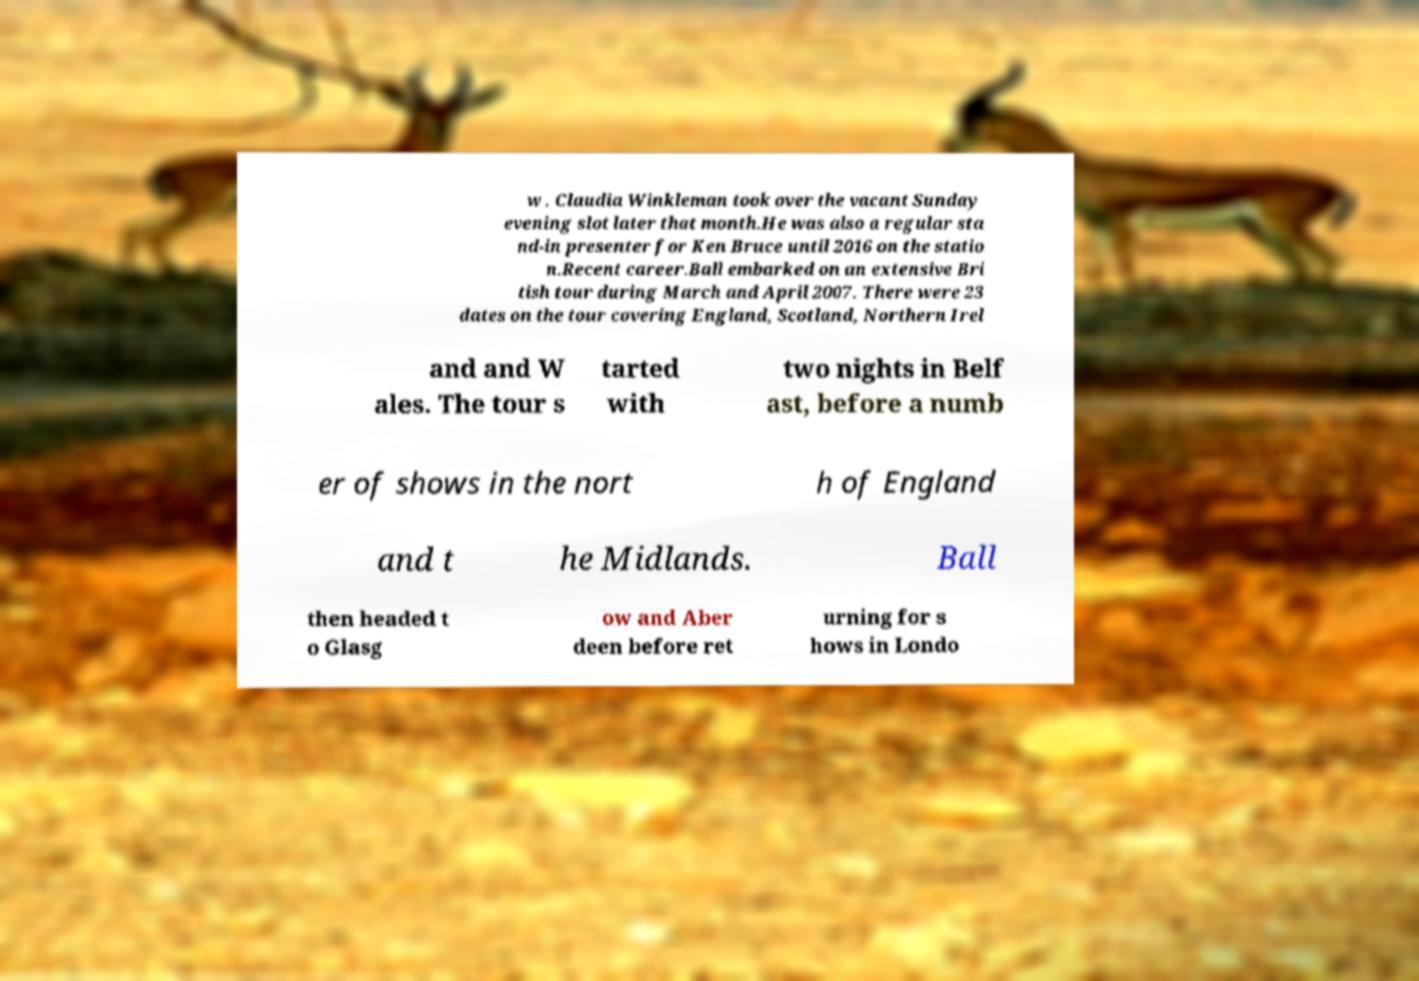Please identify and transcribe the text found in this image. w . Claudia Winkleman took over the vacant Sunday evening slot later that month.He was also a regular sta nd-in presenter for Ken Bruce until 2016 on the statio n.Recent career.Ball embarked on an extensive Bri tish tour during March and April 2007. There were 23 dates on the tour covering England, Scotland, Northern Irel and and W ales. The tour s tarted with two nights in Belf ast, before a numb er of shows in the nort h of England and t he Midlands. Ball then headed t o Glasg ow and Aber deen before ret urning for s hows in Londo 